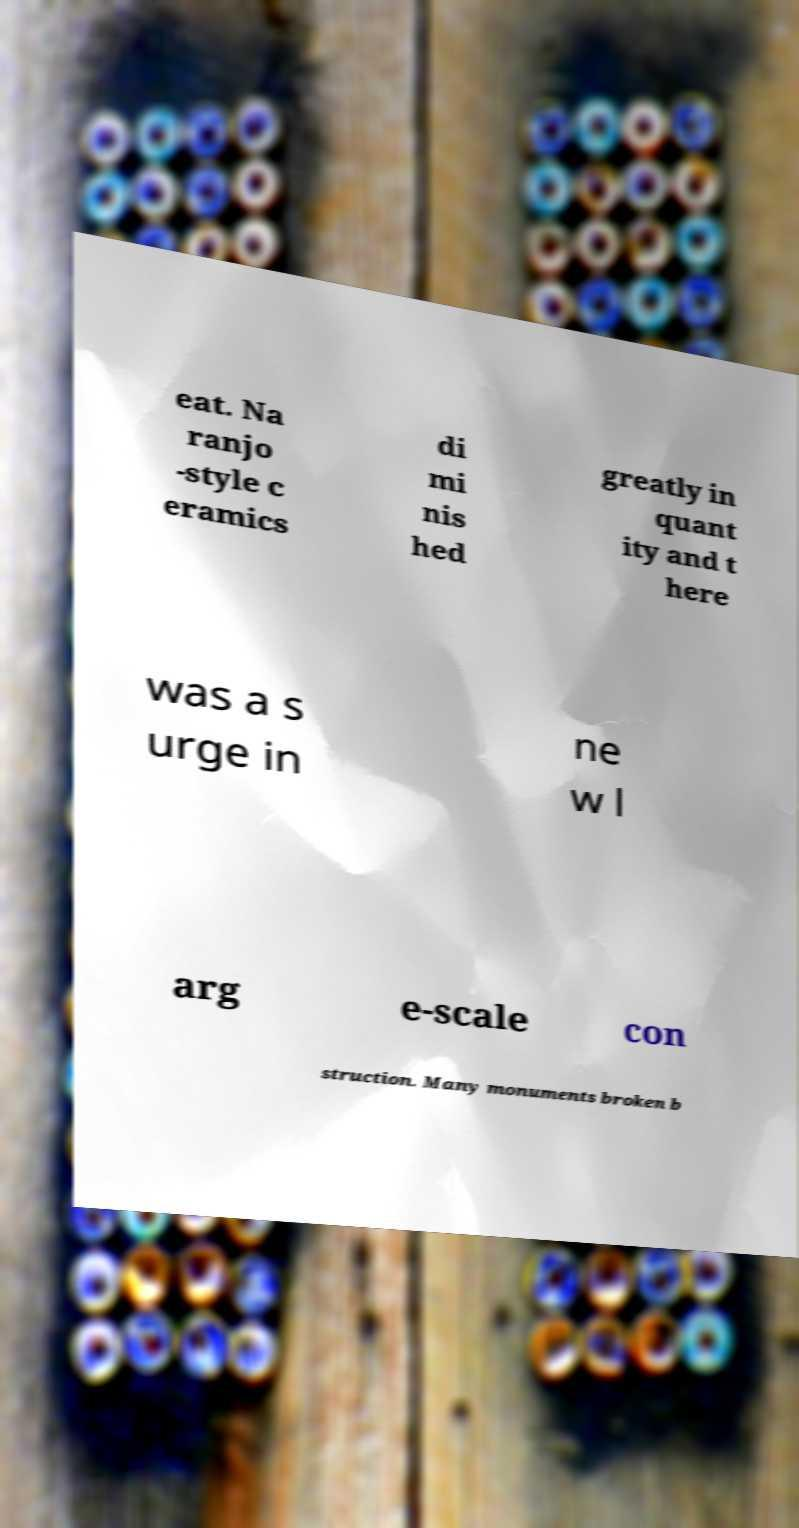There's text embedded in this image that I need extracted. Can you transcribe it verbatim? eat. Na ranjo -style c eramics di mi nis hed greatly in quant ity and t here was a s urge in ne w l arg e-scale con struction. Many monuments broken b 